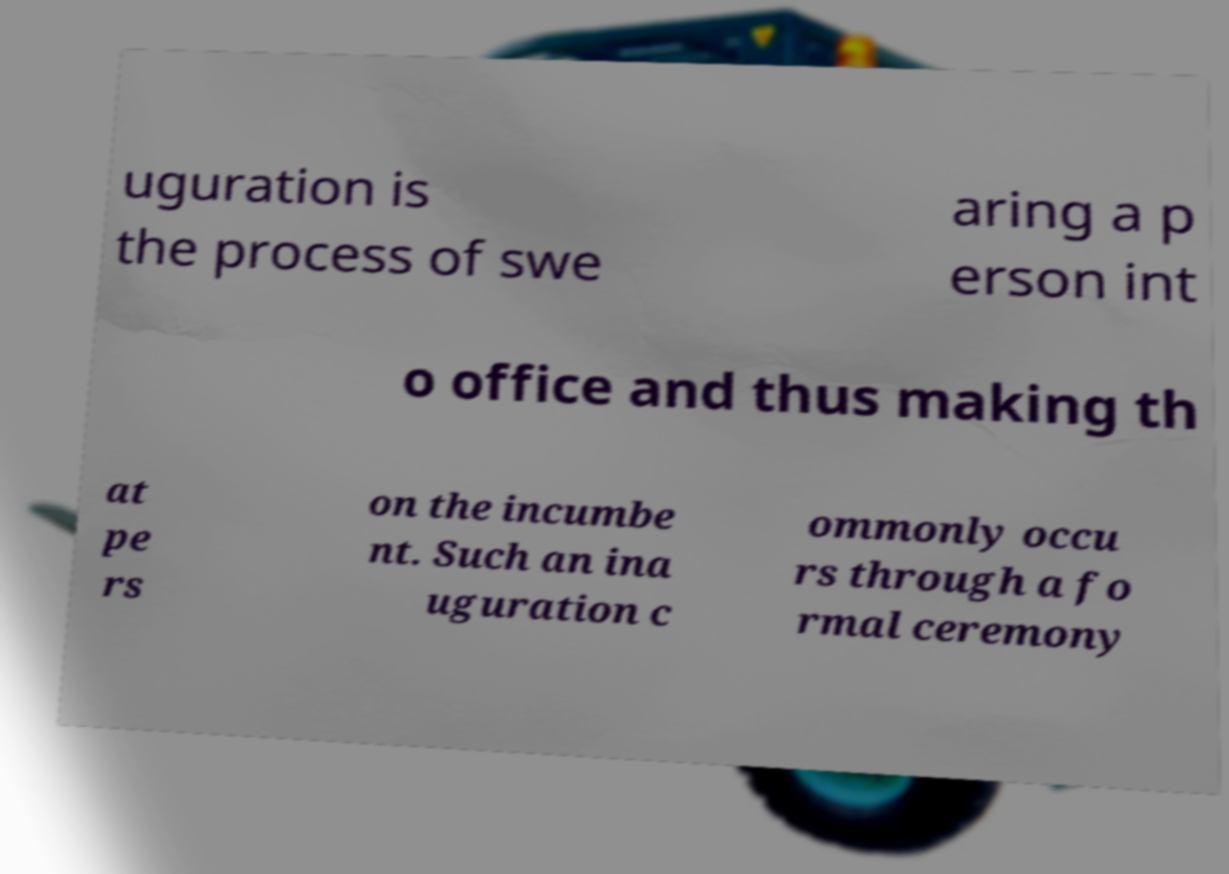Could you assist in decoding the text presented in this image and type it out clearly? uguration is the process of swe aring a p erson int o office and thus making th at pe rs on the incumbe nt. Such an ina uguration c ommonly occu rs through a fo rmal ceremony 